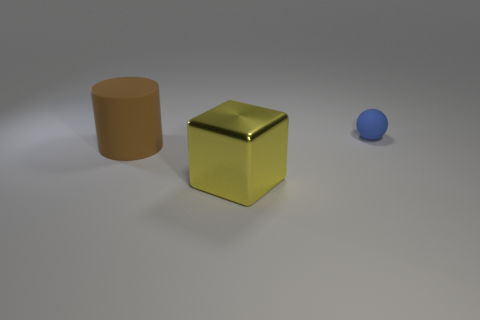Subtract 1 balls. How many balls are left? 0 Subtract all balls. How many objects are left? 2 Add 1 purple metal objects. How many objects exist? 4 Subtract all blue blocks. Subtract all gray cylinders. How many blocks are left? 1 Subtract all small blue rubber balls. Subtract all small matte spheres. How many objects are left? 1 Add 1 brown things. How many brown things are left? 2 Add 2 small yellow metallic cylinders. How many small yellow metallic cylinders exist? 2 Subtract 0 purple blocks. How many objects are left? 3 